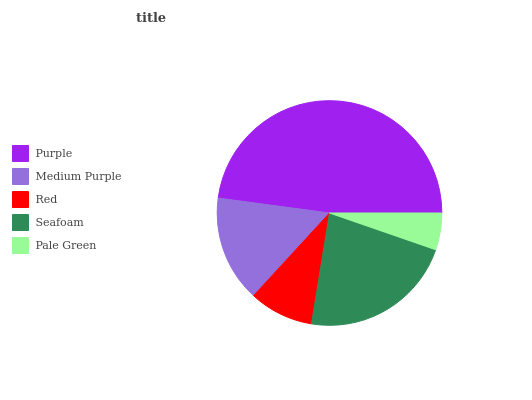Is Pale Green the minimum?
Answer yes or no. Yes. Is Purple the maximum?
Answer yes or no. Yes. Is Medium Purple the minimum?
Answer yes or no. No. Is Medium Purple the maximum?
Answer yes or no. No. Is Purple greater than Medium Purple?
Answer yes or no. Yes. Is Medium Purple less than Purple?
Answer yes or no. Yes. Is Medium Purple greater than Purple?
Answer yes or no. No. Is Purple less than Medium Purple?
Answer yes or no. No. Is Medium Purple the high median?
Answer yes or no. Yes. Is Medium Purple the low median?
Answer yes or no. Yes. Is Pale Green the high median?
Answer yes or no. No. Is Red the low median?
Answer yes or no. No. 